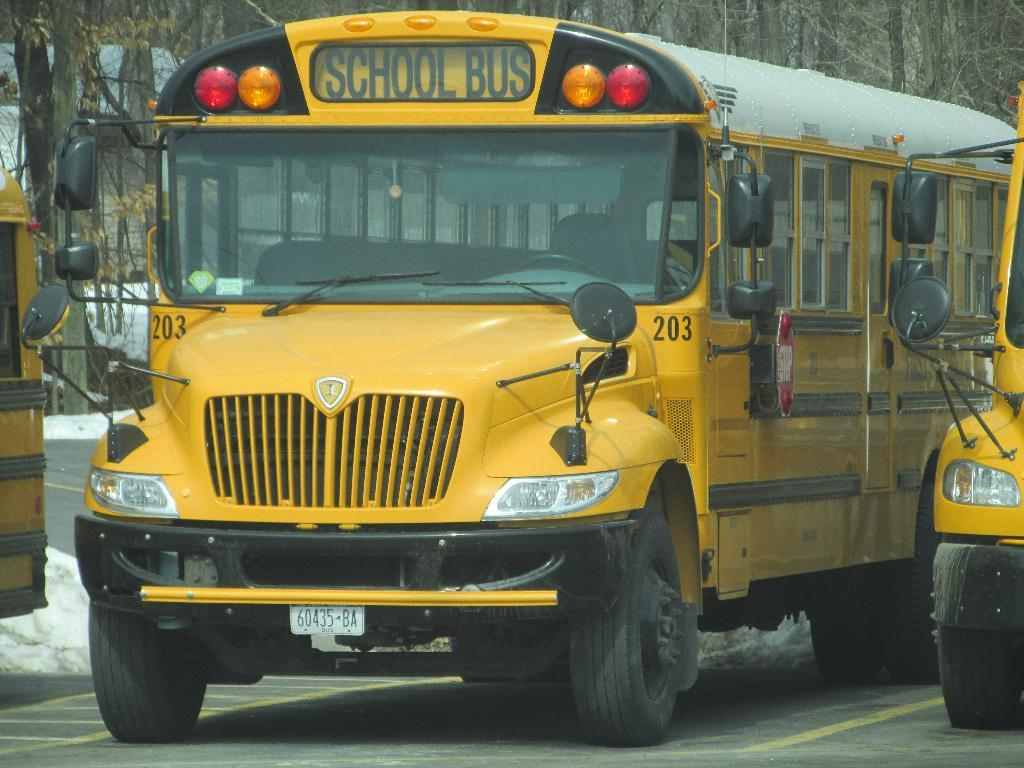What can be seen on the road in the image? There are vehicles on the road in the image. What type of natural scenery is visible in the background of the image? There are trees visible in the background of the image. Where is the pump located in the image? There is no pump present in the image. What type of throne can be seen in the image? There is no throne present in the image. 